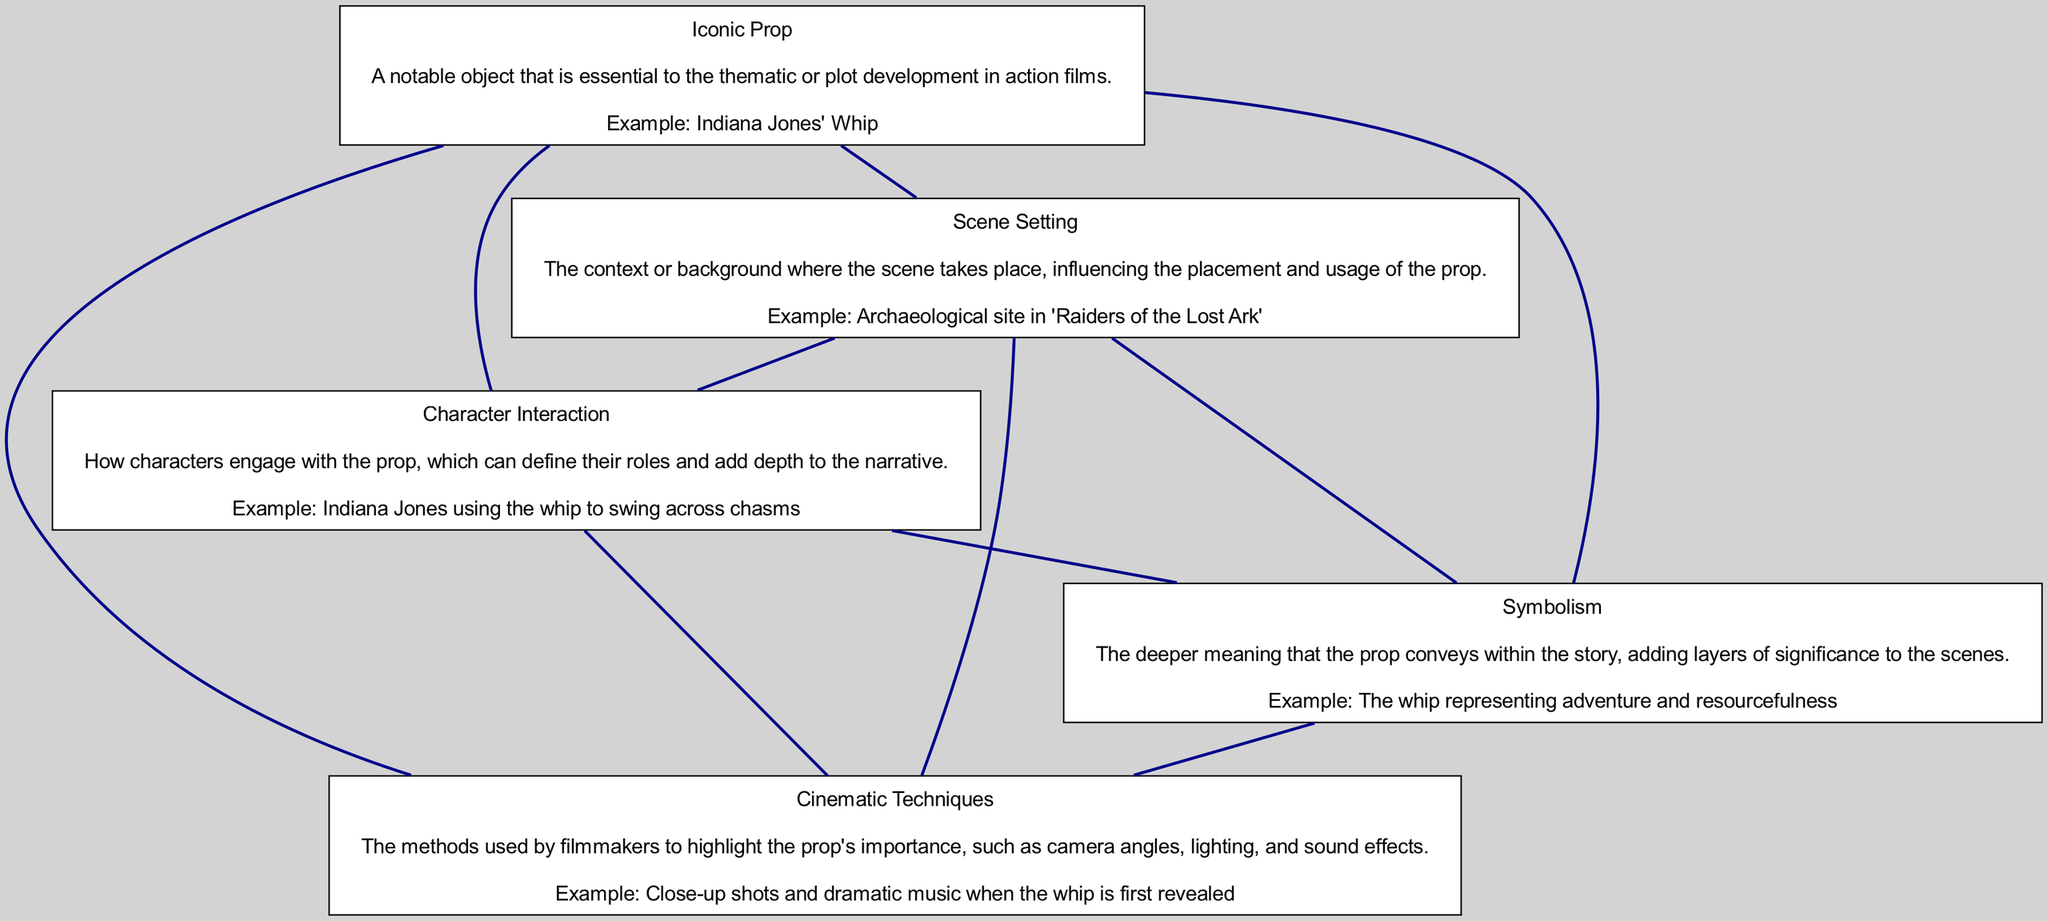What is the example of an iconic prop mentioned? The diagram lists "Indiana Jones' Whip" as the example for the Iconic Prop node. This information can be found directly in the node labeled "Iconic Prop" in the diagram.
Answer: Indiana Jones' Whip How many elements are there in the block diagram? There are five elements shown in the diagram: Iconic Prop, Scene Setting, Character Interaction, Symbolism, and Cinematic Techniques. By counting each distinct node, we arrive at this number.
Answer: 5 What is the example provided for Scene Setting? The example associated with the Scene Setting node is found clearly outlined as "Archaeological site in 'Raiders of the Lost Ark'" under its relevant node in the diagram.
Answer: Archaeological site in 'Raiders of the Lost Ark' Which element conveys a deeper meaning in the scenes? The Symbolism element is key to conveying a deeper meaning, as indicated in the diagram. It explicitly mentions the symbolic role of the iconic prop in the context of the narrative.
Answer: Symbolism How does the Character Interaction node describe the engagement with the iconic prop? The Character Interaction node states that it describes how characters engage with the prop, specifically mentioning "Indiana Jones using the whip to swing across chasms." This gives insight into the prop's practical usage in the narrative.
Answer: Indiana Jones using the whip to swing across chasms Which two elements are directly connected by an edge in the diagram? Many pairs of nodes are connected, but one clear example is the connection between the Iconic Prop and Character Interaction nodes. A visual inspection of the diagram shows an edge connecting these elements.
Answer: Iconic Prop and Character Interaction How do Cinematic Techniques highlight the importance of the prop? The Cinematic Techniques node explains that filmmakers use methods like "Close-up shots and dramatic music when the whip is first revealed." Combining these aspects reflects how the techniques emphasize the prop's significance during the scene.
Answer: Close-up shots and dramatic music What characterizes the Scene Setting within this block diagram? The Scene Setting node is characterized by its description as the context where the scene takes place, and it also mentions that it influences the placement and usage of the prop, as illustrated in the diagram.
Answer: Context or background What example illustrates the symbolism of the iconic prop? The example noted in the Symbolism node identifies the whip as representing "adventure and resourcefulness." This specific phrasing outlines what this prop embodies within the film narrative, as depicted in the diagram.
Answer: Adventure and resourcefulness 